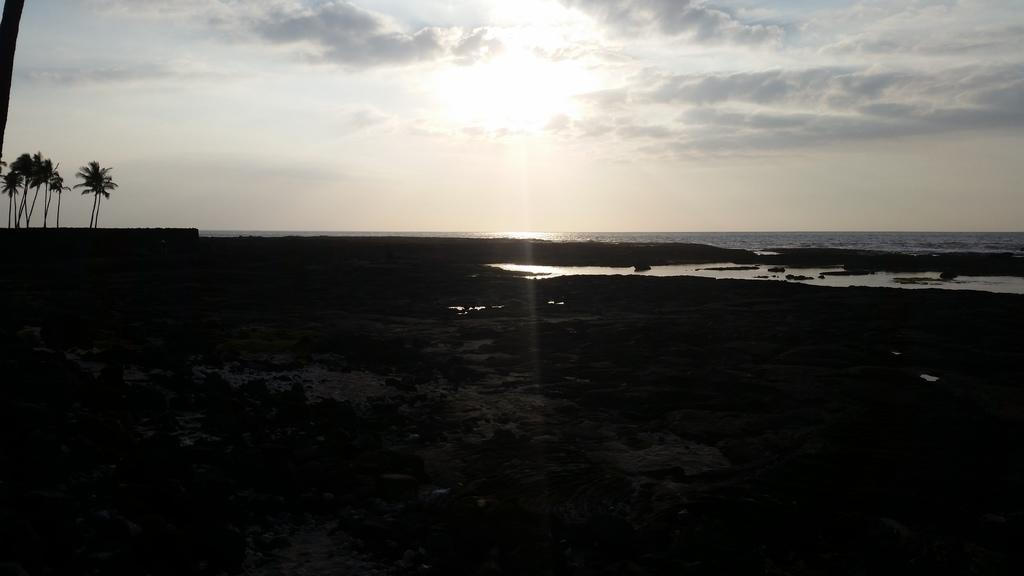What type of vegetation can be seen in the image? There are trees in the image. What natural element is visible in the image besides the trees? There is water visible in the image. What can be seen in the background of the image? The sky is visible in the background of the image. How is the sunlight affecting the scene in the image? Sunlight is falling towards the ground in the image. What is the texture of the egg in the image? There is no egg present in the image. 